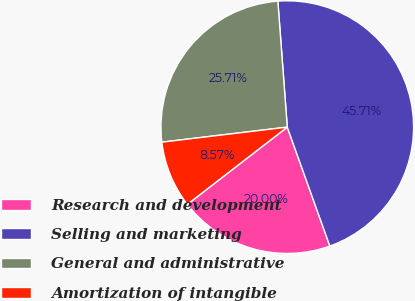Convert chart. <chart><loc_0><loc_0><loc_500><loc_500><pie_chart><fcel>Research and development<fcel>Selling and marketing<fcel>General and administrative<fcel>Amortization of intangible<nl><fcel>20.0%<fcel>45.71%<fcel>25.71%<fcel>8.57%<nl></chart> 